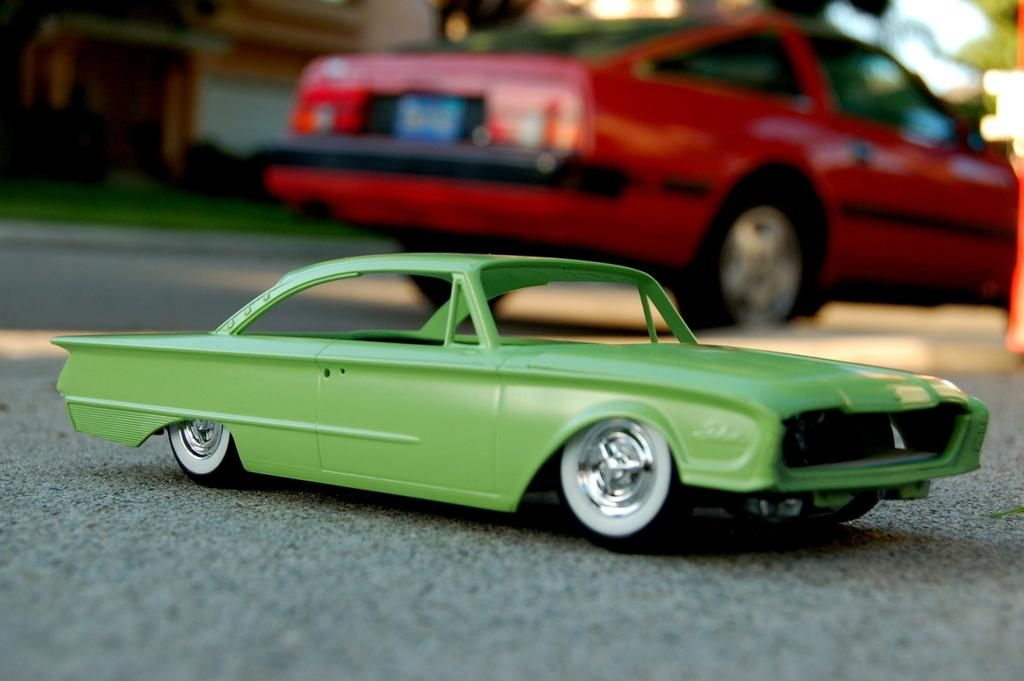What type of toy is in the image? There is a car toy in the image. Where is the car toy located? The car toy is on the road. Are there any other cars in the image? Yes, there is a car parked on the road. Can you describe the background of the image? The background of the image is slightly blurry. What type of gold object can be seen in the image? There is no gold object present in the image. Can you hear the sound of a beggar in the image? The image is silent, and there is no indication of a beggar or any sound. 